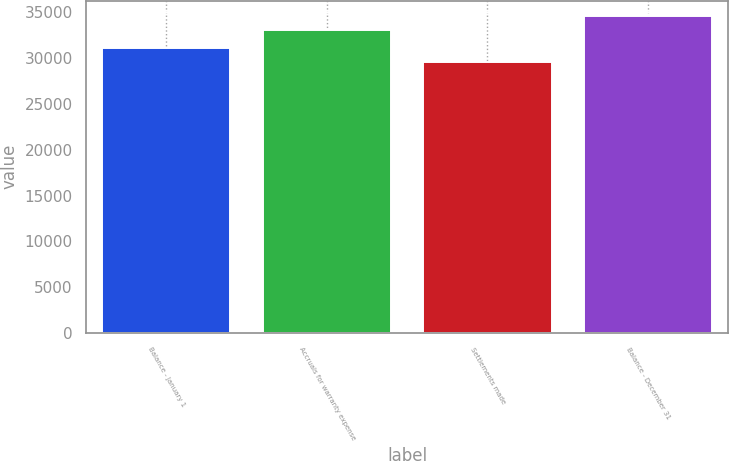<chart> <loc_0><loc_0><loc_500><loc_500><bar_chart><fcel>Balance - January 1<fcel>Accruals for warranty expense<fcel>Settlements made<fcel>Balance - December 31<nl><fcel>31095<fcel>33113<fcel>29634<fcel>34574<nl></chart> 